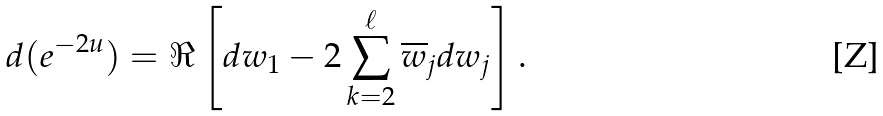<formula> <loc_0><loc_0><loc_500><loc_500>d ( e ^ { - 2 u } ) = \Re \left [ d w _ { 1 } - 2 \sum _ { k = 2 } ^ { \ell } \overline { w } _ { j } d w _ { j } \right ] .</formula> 